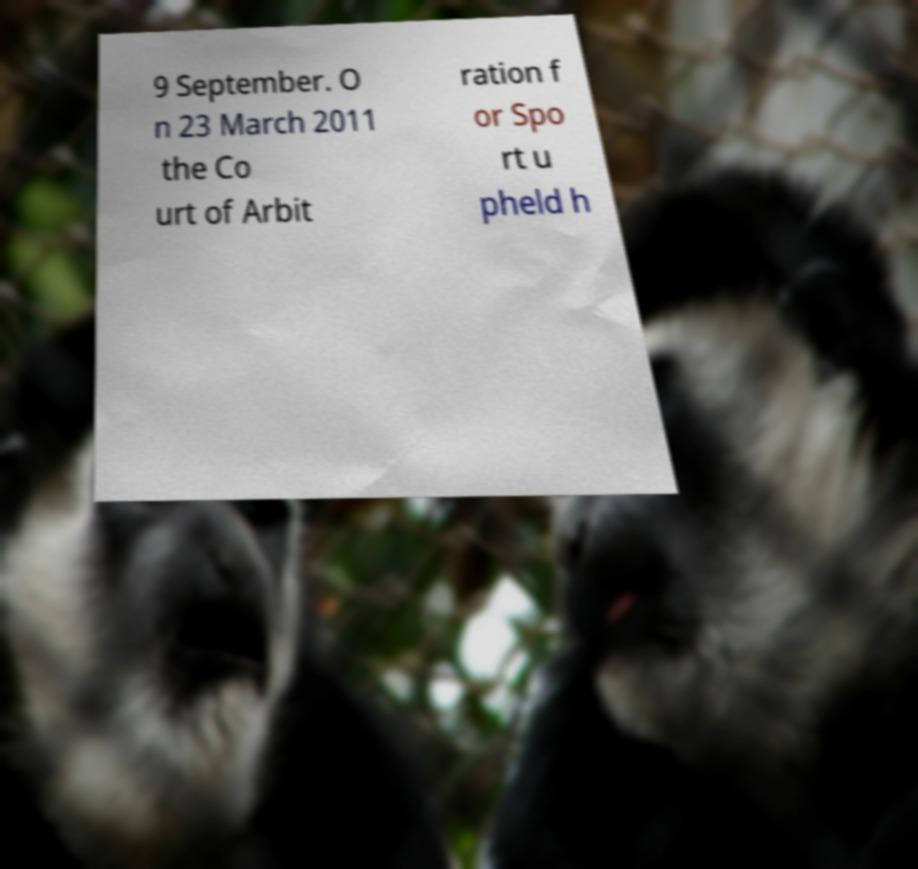Can you read and provide the text displayed in the image?This photo seems to have some interesting text. Can you extract and type it out for me? 9 September. O n 23 March 2011 the Co urt of Arbit ration f or Spo rt u pheld h 